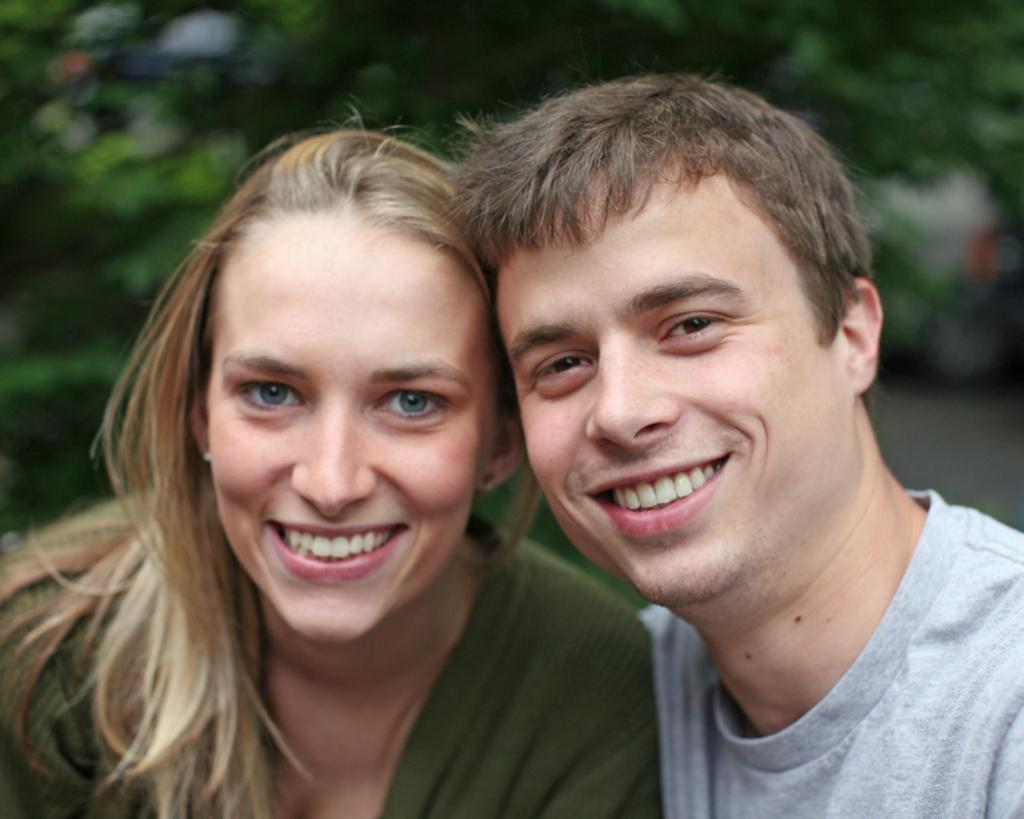Who is present in the image? There is a man and a woman in the image. What are the expressions on their faces? Both the man and the woman are smiling. What can be seen in the background of the image? There are trees in the background of the image. How would you describe the background's appearance? The background appears blurry. What parcel is the man holding in the image? There is no parcel visible in the image. What type of pleasure is the woman experiencing in the image? The image does not provide information about the woman's specific pleasure. 